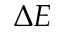Convert formula to latex. <formula><loc_0><loc_0><loc_500><loc_500>\Delta E</formula> 